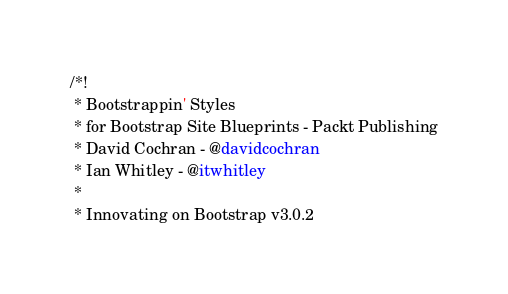Convert code to text. <code><loc_0><loc_0><loc_500><loc_500><_CSS_>/*!
 * Bootstrappin' Styles
 * for Bootstrap Site Blueprints - Packt Publishing
 * David Cochran - @davidcochran
 * Ian Whitley - @itwhitley
 *
 * Innovating on Bootstrap v3.0.2</code> 